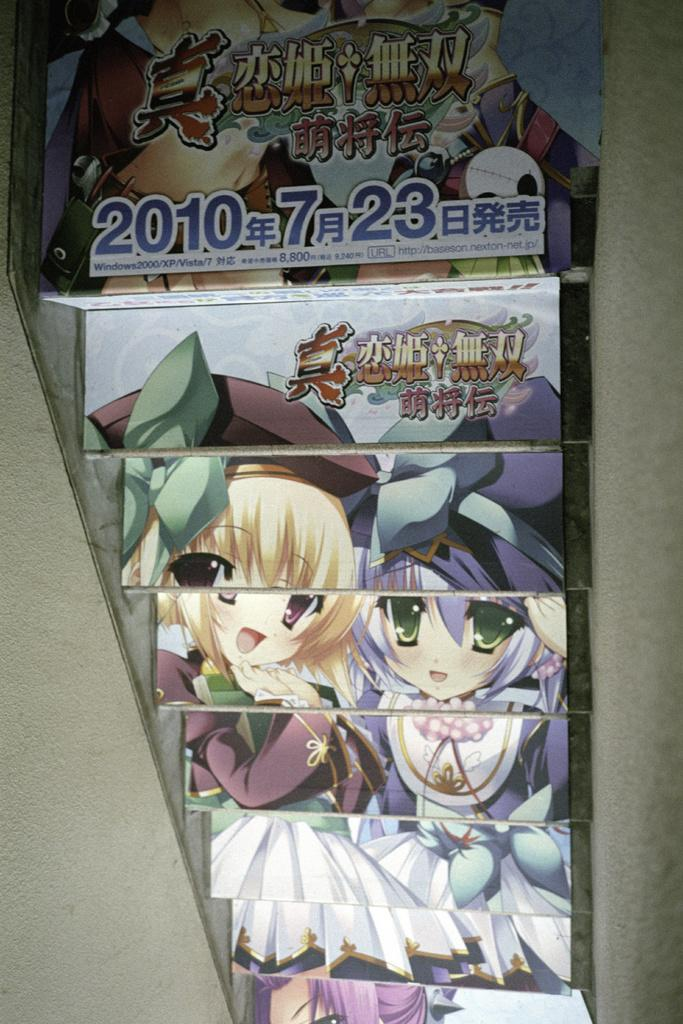What type of objects are arranged in the racks in the image? The image contains books arranged in racks. How are the books organized in the racks? The provided facts do not specify how the books are organized in the racks. Can you describe the color or size of the books in the image? The provided facts do not specify the color or size of the books in the image. How many rabbits can be seen hopping around the tank in the image? There is no tank or rabbits present in the image; it contains books arranged in racks. 